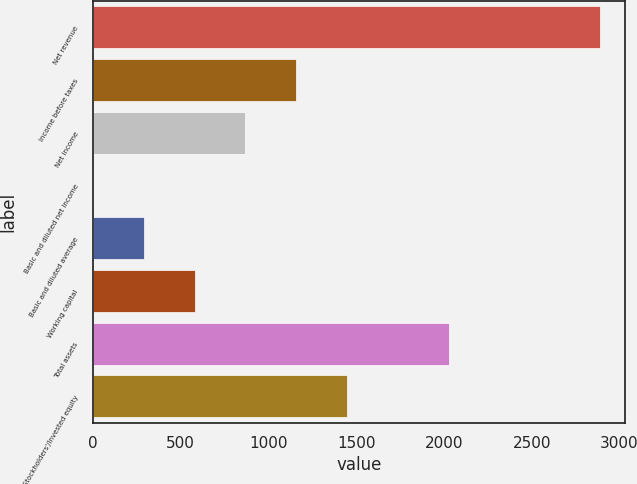Convert chart. <chart><loc_0><loc_0><loc_500><loc_500><bar_chart><fcel>Net revenue<fcel>Income before taxes<fcel>Net income<fcel>Basic and diluted net income<fcel>Basic and diluted average<fcel>Working capital<fcel>Total assets<fcel>Stockholders'/Invested equity<nl><fcel>2888<fcel>1156.86<fcel>868.33<fcel>2.74<fcel>291.27<fcel>579.8<fcel>2028<fcel>1445.39<nl></chart> 